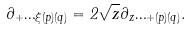<formula> <loc_0><loc_0><loc_500><loc_500>\partial _ { + } \Phi _ { \xi ( p ) ( q ) } = 2 \sqrt { z } \partial _ { z } \Phi _ { + ( p ) ( q ) } .</formula> 